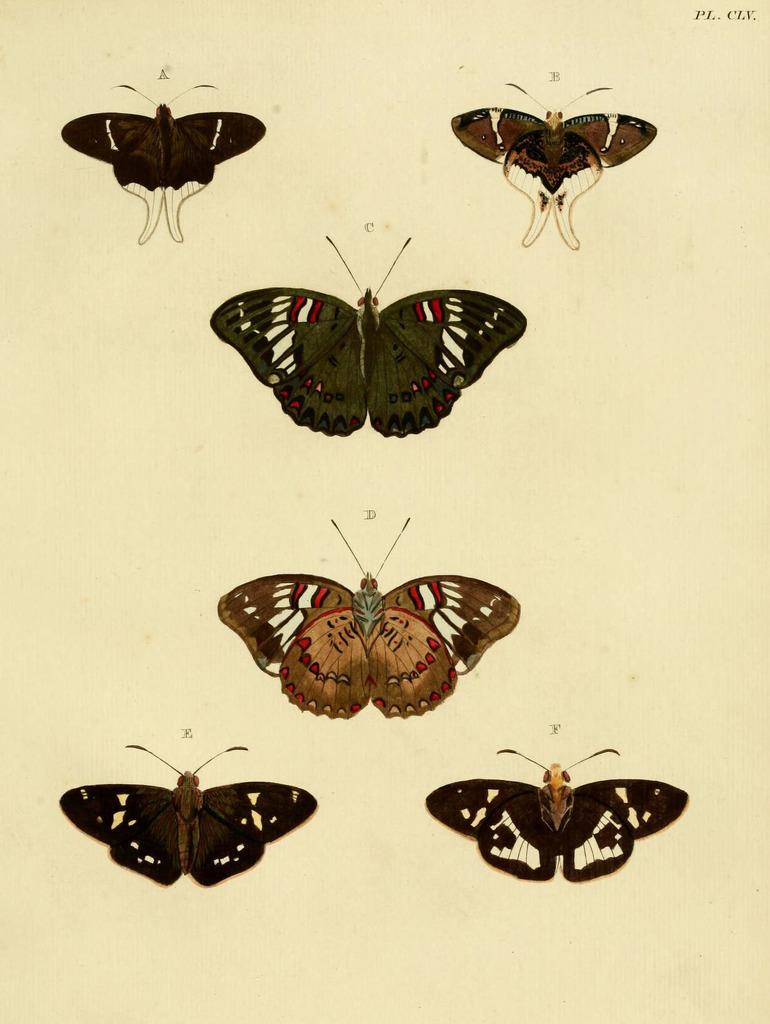What is depicted in the images in the picture? There are images of butterflies in the picture. What color is the background of the image? The background of the image is white. Where is the text located in the image? The text is in the top right corner of the image. What type of record can be seen in the image? There is no record present in the image; it features images of butterflies and text on a white background. Is there a scarecrow visible in the image? No, there is no scarecrow present in the image. 